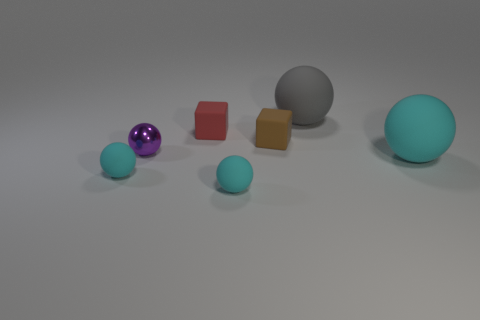There is a brown rubber object that is the same size as the shiny sphere; what is its shape?
Your response must be concise. Cube. How many other objects are there of the same shape as the purple metal object?
Offer a very short reply. 4. Does the red matte block have the same size as the thing behind the tiny red matte block?
Your answer should be compact. No. What number of objects are cyan balls to the left of the big gray sphere or tiny rubber cubes?
Provide a succinct answer. 4. What is the shape of the big rubber object that is behind the tiny shiny thing?
Keep it short and to the point. Sphere. Are there the same number of red things to the right of the big cyan ball and tiny cyan rubber spheres left of the tiny metallic sphere?
Offer a very short reply. No. There is a matte object that is both behind the big cyan sphere and to the right of the brown rubber object; what color is it?
Your answer should be very brief. Gray. What material is the small ball behind the large object in front of the tiny brown rubber cube?
Keep it short and to the point. Metal. Do the purple shiny ball and the gray thing have the same size?
Make the answer very short. No. What number of large things are purple spheres or spheres?
Your answer should be very brief. 2. 